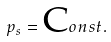<formula> <loc_0><loc_0><loc_500><loc_500>p _ { s } = { \mbox C o n s t . }</formula> 